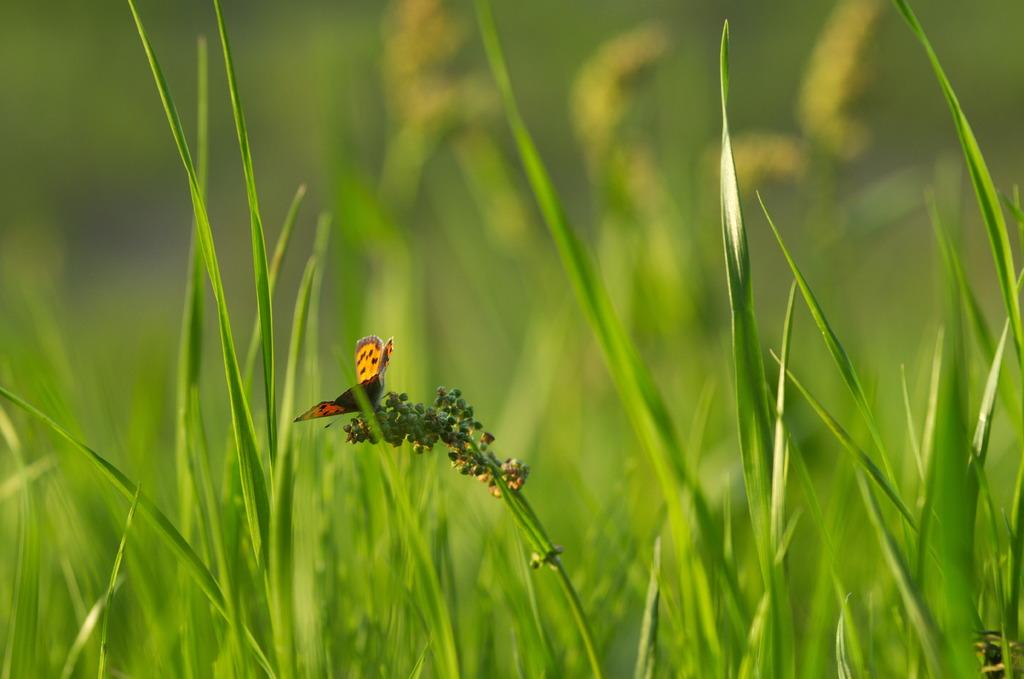What type of animal can be seen in the image? There is a butterfly in the image. What else is present in the image besides the butterfly? There are plants in the image. Can you describe the background of the image? The background of the image is blurry. How many chairs are visible in the image? There are no chairs present in the image. What type of flower is the butterfly sitting on in the image? There is no flower present in the image; only the butterfly and plants are visible. 